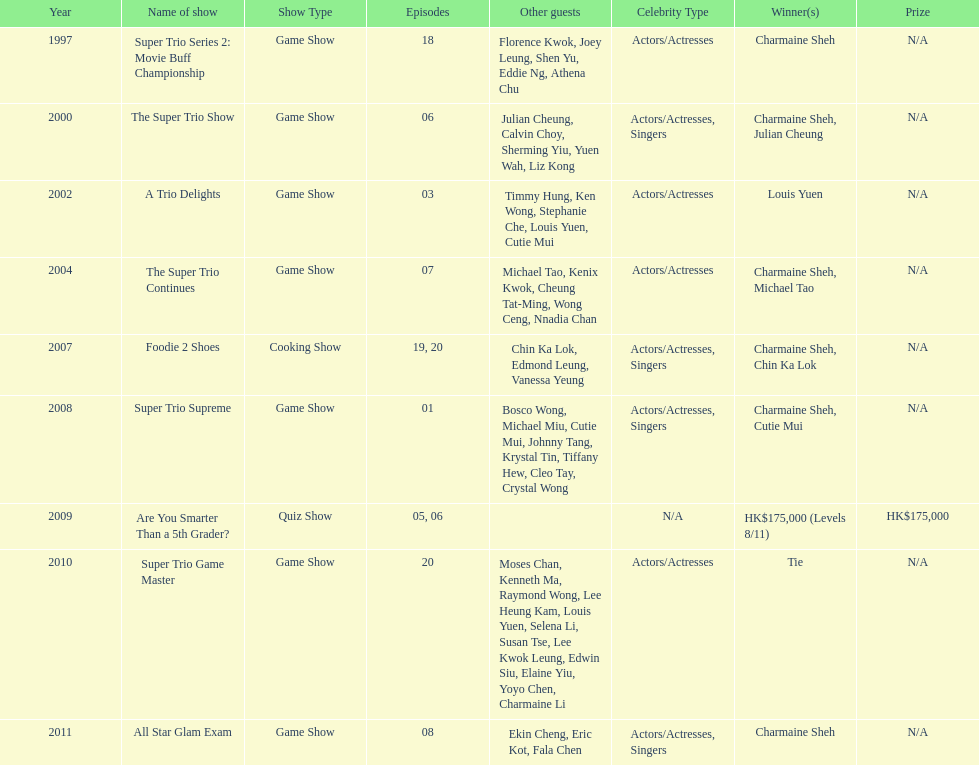For the super trio 2: movie buff champions variety show, how many episodes included charmaine sheh's participation? 18. 